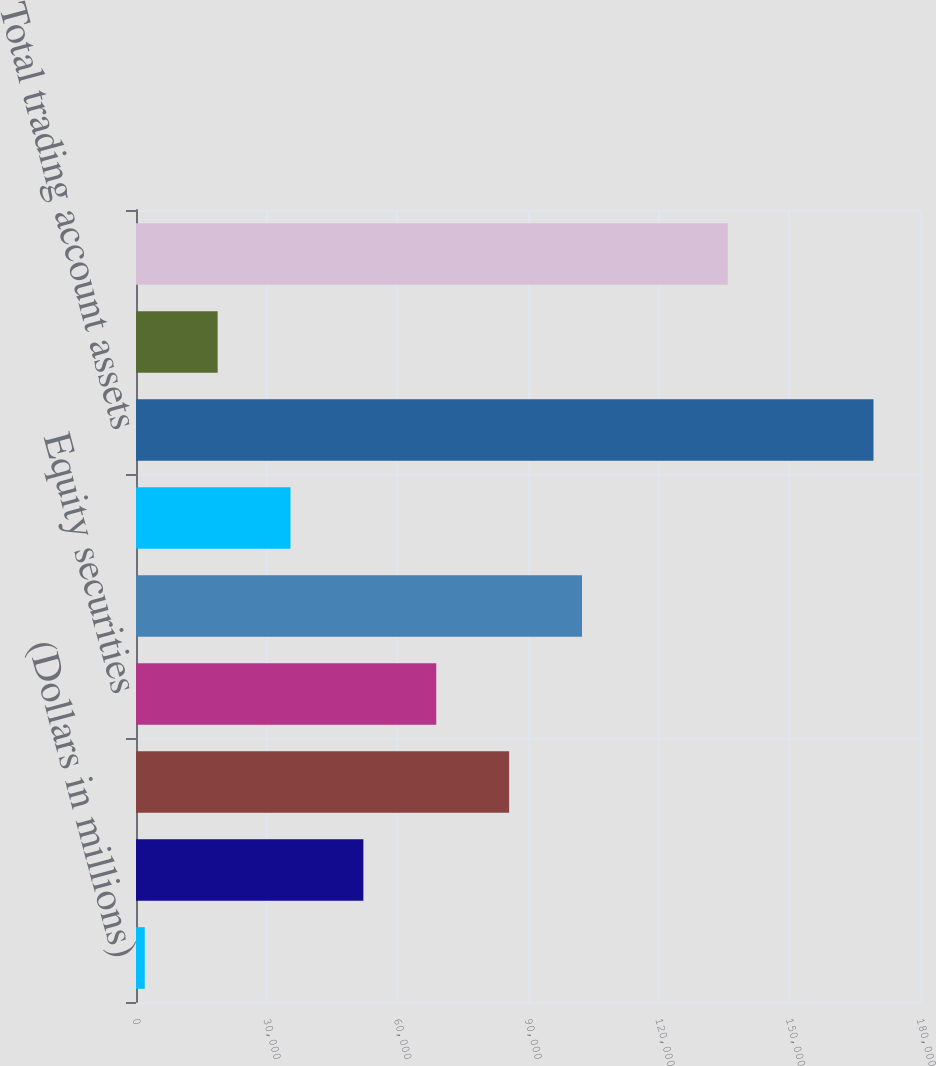<chart> <loc_0><loc_0><loc_500><loc_500><bar_chart><fcel>(Dollars in millions)<fcel>US government and agency<fcel>Corporate securities trading<fcel>Equity securities<fcel>Non-US sovereign debt<fcel>Mortgage trading loans and<fcel>Total trading account assets<fcel>Corporate securities and other<fcel>Total trading account<nl><fcel>2011<fcel>52203.4<fcel>85665<fcel>68934.2<fcel>102396<fcel>35472.6<fcel>169319<fcel>18741.8<fcel>135857<nl></chart> 